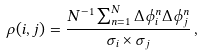Convert formula to latex. <formula><loc_0><loc_0><loc_500><loc_500>\rho ( i , j ) = \frac { N ^ { - 1 } \sum _ { n = 1 } ^ { N } \Delta \phi _ { i } ^ { n } \Delta \phi _ { j } ^ { n } } { \sigma _ { i } \times \sigma _ { j } } \, ,</formula> 